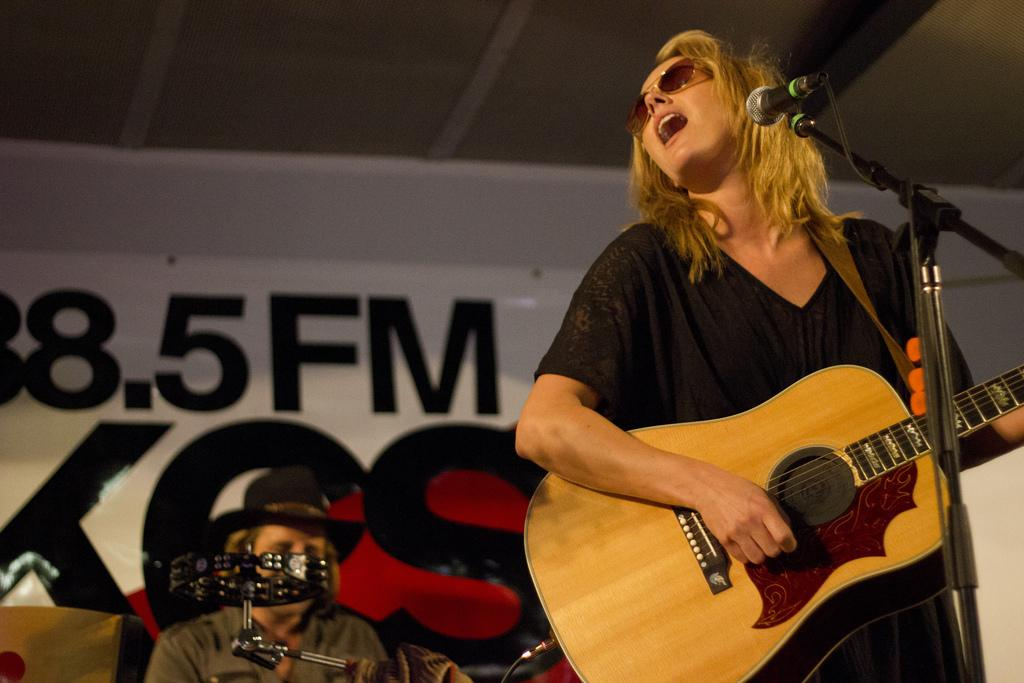What is the woman wearing in the image? The woman is wearing a black dress and goggles. What is the woman doing in the image? The woman is playing a guitar and is in front of a microphone. What can be seen near the woman in the image? There is a mic holder in the image. What is the man doing in the image? The man is sitting and wearing a hat. What other object related to music can be seen in the image? There is a musical instrument in the image. What is on the wall in the image? There is a banner on the wall. What grade is the bat flying in the image? There is no bat present in the image. What type of cloud can be seen in the background of the image? There is no cloud visible in the image. 